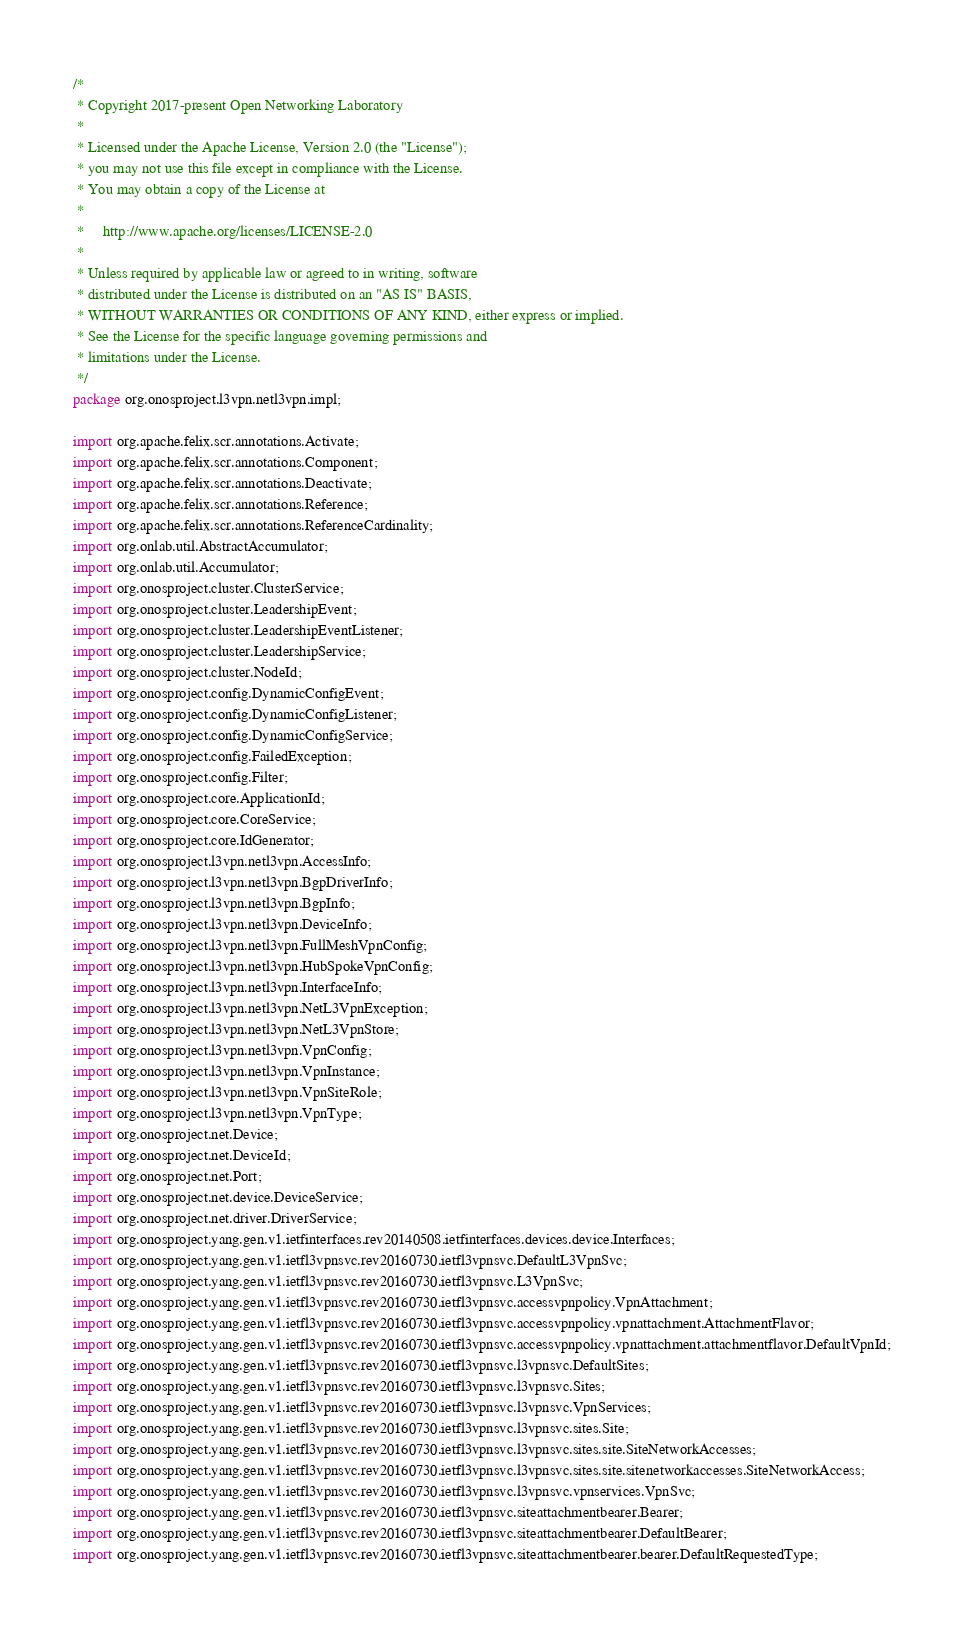Convert code to text. <code><loc_0><loc_0><loc_500><loc_500><_Java_>/*
 * Copyright 2017-present Open Networking Laboratory
 *
 * Licensed under the Apache License, Version 2.0 (the "License");
 * you may not use this file except in compliance with the License.
 * You may obtain a copy of the License at
 *
 *     http://www.apache.org/licenses/LICENSE-2.0
 *
 * Unless required by applicable law or agreed to in writing, software
 * distributed under the License is distributed on an "AS IS" BASIS,
 * WITHOUT WARRANTIES OR CONDITIONS OF ANY KIND, either express or implied.
 * See the License for the specific language governing permissions and
 * limitations under the License.
 */
package org.onosproject.l3vpn.netl3vpn.impl;

import org.apache.felix.scr.annotations.Activate;
import org.apache.felix.scr.annotations.Component;
import org.apache.felix.scr.annotations.Deactivate;
import org.apache.felix.scr.annotations.Reference;
import org.apache.felix.scr.annotations.ReferenceCardinality;
import org.onlab.util.AbstractAccumulator;
import org.onlab.util.Accumulator;
import org.onosproject.cluster.ClusterService;
import org.onosproject.cluster.LeadershipEvent;
import org.onosproject.cluster.LeadershipEventListener;
import org.onosproject.cluster.LeadershipService;
import org.onosproject.cluster.NodeId;
import org.onosproject.config.DynamicConfigEvent;
import org.onosproject.config.DynamicConfigListener;
import org.onosproject.config.DynamicConfigService;
import org.onosproject.config.FailedException;
import org.onosproject.config.Filter;
import org.onosproject.core.ApplicationId;
import org.onosproject.core.CoreService;
import org.onosproject.core.IdGenerator;
import org.onosproject.l3vpn.netl3vpn.AccessInfo;
import org.onosproject.l3vpn.netl3vpn.BgpDriverInfo;
import org.onosproject.l3vpn.netl3vpn.BgpInfo;
import org.onosproject.l3vpn.netl3vpn.DeviceInfo;
import org.onosproject.l3vpn.netl3vpn.FullMeshVpnConfig;
import org.onosproject.l3vpn.netl3vpn.HubSpokeVpnConfig;
import org.onosproject.l3vpn.netl3vpn.InterfaceInfo;
import org.onosproject.l3vpn.netl3vpn.NetL3VpnException;
import org.onosproject.l3vpn.netl3vpn.NetL3VpnStore;
import org.onosproject.l3vpn.netl3vpn.VpnConfig;
import org.onosproject.l3vpn.netl3vpn.VpnInstance;
import org.onosproject.l3vpn.netl3vpn.VpnSiteRole;
import org.onosproject.l3vpn.netl3vpn.VpnType;
import org.onosproject.net.Device;
import org.onosproject.net.DeviceId;
import org.onosproject.net.Port;
import org.onosproject.net.device.DeviceService;
import org.onosproject.net.driver.DriverService;
import org.onosproject.yang.gen.v1.ietfinterfaces.rev20140508.ietfinterfaces.devices.device.Interfaces;
import org.onosproject.yang.gen.v1.ietfl3vpnsvc.rev20160730.ietfl3vpnsvc.DefaultL3VpnSvc;
import org.onosproject.yang.gen.v1.ietfl3vpnsvc.rev20160730.ietfl3vpnsvc.L3VpnSvc;
import org.onosproject.yang.gen.v1.ietfl3vpnsvc.rev20160730.ietfl3vpnsvc.accessvpnpolicy.VpnAttachment;
import org.onosproject.yang.gen.v1.ietfl3vpnsvc.rev20160730.ietfl3vpnsvc.accessvpnpolicy.vpnattachment.AttachmentFlavor;
import org.onosproject.yang.gen.v1.ietfl3vpnsvc.rev20160730.ietfl3vpnsvc.accessvpnpolicy.vpnattachment.attachmentflavor.DefaultVpnId;
import org.onosproject.yang.gen.v1.ietfl3vpnsvc.rev20160730.ietfl3vpnsvc.l3vpnsvc.DefaultSites;
import org.onosproject.yang.gen.v1.ietfl3vpnsvc.rev20160730.ietfl3vpnsvc.l3vpnsvc.Sites;
import org.onosproject.yang.gen.v1.ietfl3vpnsvc.rev20160730.ietfl3vpnsvc.l3vpnsvc.VpnServices;
import org.onosproject.yang.gen.v1.ietfl3vpnsvc.rev20160730.ietfl3vpnsvc.l3vpnsvc.sites.Site;
import org.onosproject.yang.gen.v1.ietfl3vpnsvc.rev20160730.ietfl3vpnsvc.l3vpnsvc.sites.site.SiteNetworkAccesses;
import org.onosproject.yang.gen.v1.ietfl3vpnsvc.rev20160730.ietfl3vpnsvc.l3vpnsvc.sites.site.sitenetworkaccesses.SiteNetworkAccess;
import org.onosproject.yang.gen.v1.ietfl3vpnsvc.rev20160730.ietfl3vpnsvc.l3vpnsvc.vpnservices.VpnSvc;
import org.onosproject.yang.gen.v1.ietfl3vpnsvc.rev20160730.ietfl3vpnsvc.siteattachmentbearer.Bearer;
import org.onosproject.yang.gen.v1.ietfl3vpnsvc.rev20160730.ietfl3vpnsvc.siteattachmentbearer.DefaultBearer;
import org.onosproject.yang.gen.v1.ietfl3vpnsvc.rev20160730.ietfl3vpnsvc.siteattachmentbearer.bearer.DefaultRequestedType;</code> 